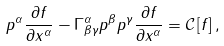Convert formula to latex. <formula><loc_0><loc_0><loc_500><loc_500>p ^ { \alpha } \frac { \partial f } { \partial x ^ { \alpha } } - \Gamma ^ { \alpha } _ { \beta \gamma } p ^ { \beta } p ^ { \gamma } \frac { \partial f } { \partial x ^ { \alpha } } = \mathcal { C } \left [ f \right ] ,</formula> 